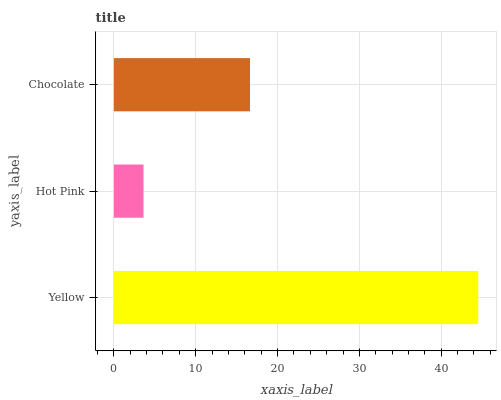Is Hot Pink the minimum?
Answer yes or no. Yes. Is Yellow the maximum?
Answer yes or no. Yes. Is Chocolate the minimum?
Answer yes or no. No. Is Chocolate the maximum?
Answer yes or no. No. Is Chocolate greater than Hot Pink?
Answer yes or no. Yes. Is Hot Pink less than Chocolate?
Answer yes or no. Yes. Is Hot Pink greater than Chocolate?
Answer yes or no. No. Is Chocolate less than Hot Pink?
Answer yes or no. No. Is Chocolate the high median?
Answer yes or no. Yes. Is Chocolate the low median?
Answer yes or no. Yes. Is Hot Pink the high median?
Answer yes or no. No. Is Yellow the low median?
Answer yes or no. No. 